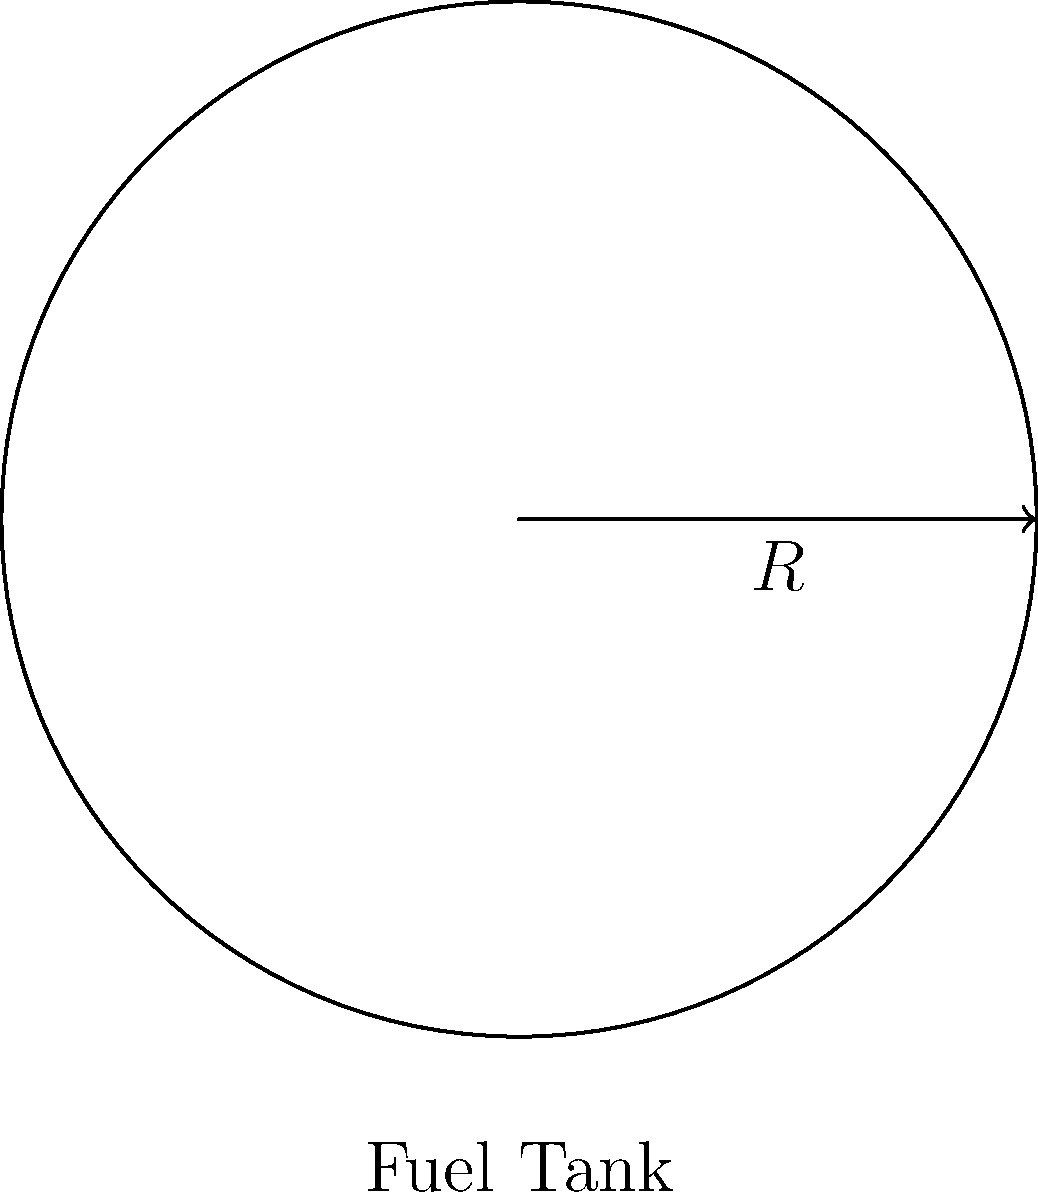As a rocket scientist, you are designing a spherical fuel tank for a spacecraft. The tank has a radius of 3 meters. Calculate the surface area of the fuel tank to determine the amount of material needed for its construction. Round your answer to the nearest square meter. To calculate the surface area of a spherical fuel tank, we can use the formula for the surface area of a sphere:

$$A = 4\pi r^2$$

Where:
$A$ is the surface area
$r$ is the radius of the sphere

Given:
Radius ($r$) = 3 meters

Step 1: Substitute the radius into the formula
$$A = 4\pi (3)^2$$

Step 2: Calculate the square of the radius
$$A = 4\pi (9)$$

Step 3: Multiply by 4π
$$A = 36\pi$$

Step 4: Calculate the final value (π ≈ 3.14159)
$$A = 36 * 3.14159 = 113.09724$$

Step 5: Round to the nearest square meter
$$A ≈ 113 \text{ m}^2$$

Therefore, the surface area of the spherical fuel tank is approximately 113 square meters.
Answer: 113 m² 